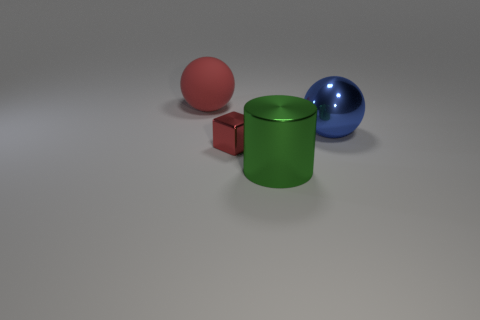Are there any other things that are the same shape as the green metal object?
Offer a terse response. No. There is a large object that is the same color as the tiny metallic cube; what is it made of?
Your response must be concise. Rubber. Are there any small shiny blocks that have the same color as the rubber object?
Your answer should be compact. Yes. Is the tiny block the same color as the large rubber thing?
Provide a succinct answer. Yes. There is a big sphere in front of the large thing behind the metal ball; what is it made of?
Your response must be concise. Metal. What material is the other big thing that is the same shape as the big rubber object?
Offer a very short reply. Metal. There is a red matte thing that is behind the green object; does it have the same size as the tiny object?
Keep it short and to the point. No. How many metallic things are either brown cylinders or small red cubes?
Give a very brief answer. 1. What is the material of the big thing that is to the left of the blue sphere and behind the big shiny cylinder?
Offer a terse response. Rubber. Does the large blue object have the same material as the red cube?
Keep it short and to the point. Yes. 